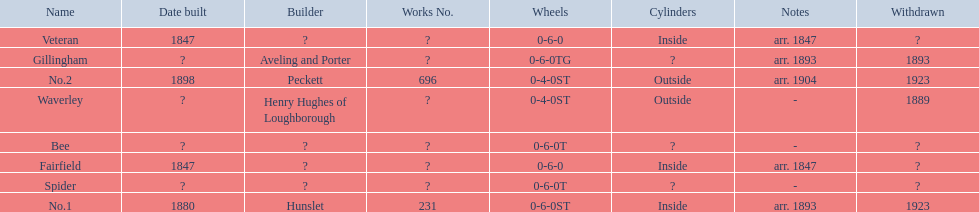Which have known built dates? Veteran, Fairfield, No.1, No.2. What other was built in 1847? Veteran. 